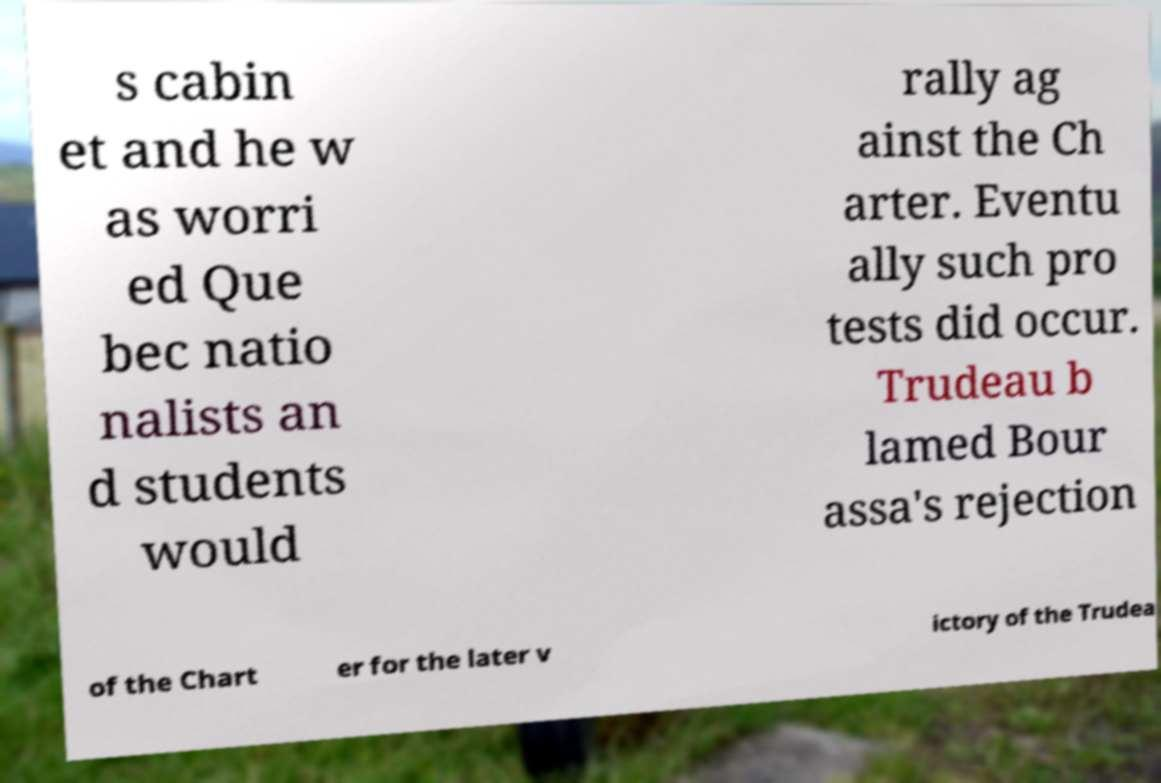Can you accurately transcribe the text from the provided image for me? s cabin et and he w as worri ed Que bec natio nalists an d students would rally ag ainst the Ch arter. Eventu ally such pro tests did occur. Trudeau b lamed Bour assa's rejection of the Chart er for the later v ictory of the Trudea 